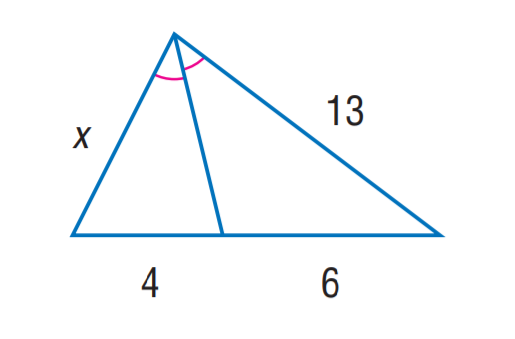Answer the mathemtical geometry problem and directly provide the correct option letter.
Question: Find x.
Choices: A: \frac { 4 } { 3 } B: \frac { 13 } { 3 } C: 6 D: \frac { 26 } { 3 } D 